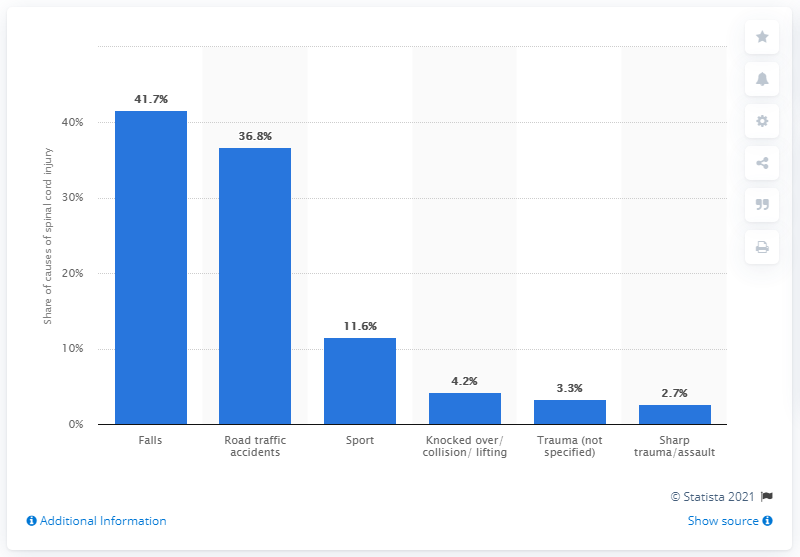Outline some significant characteristics in this image. According to a study, approximately 11.6% of sports-related accidents result in spinal cord injuries. 